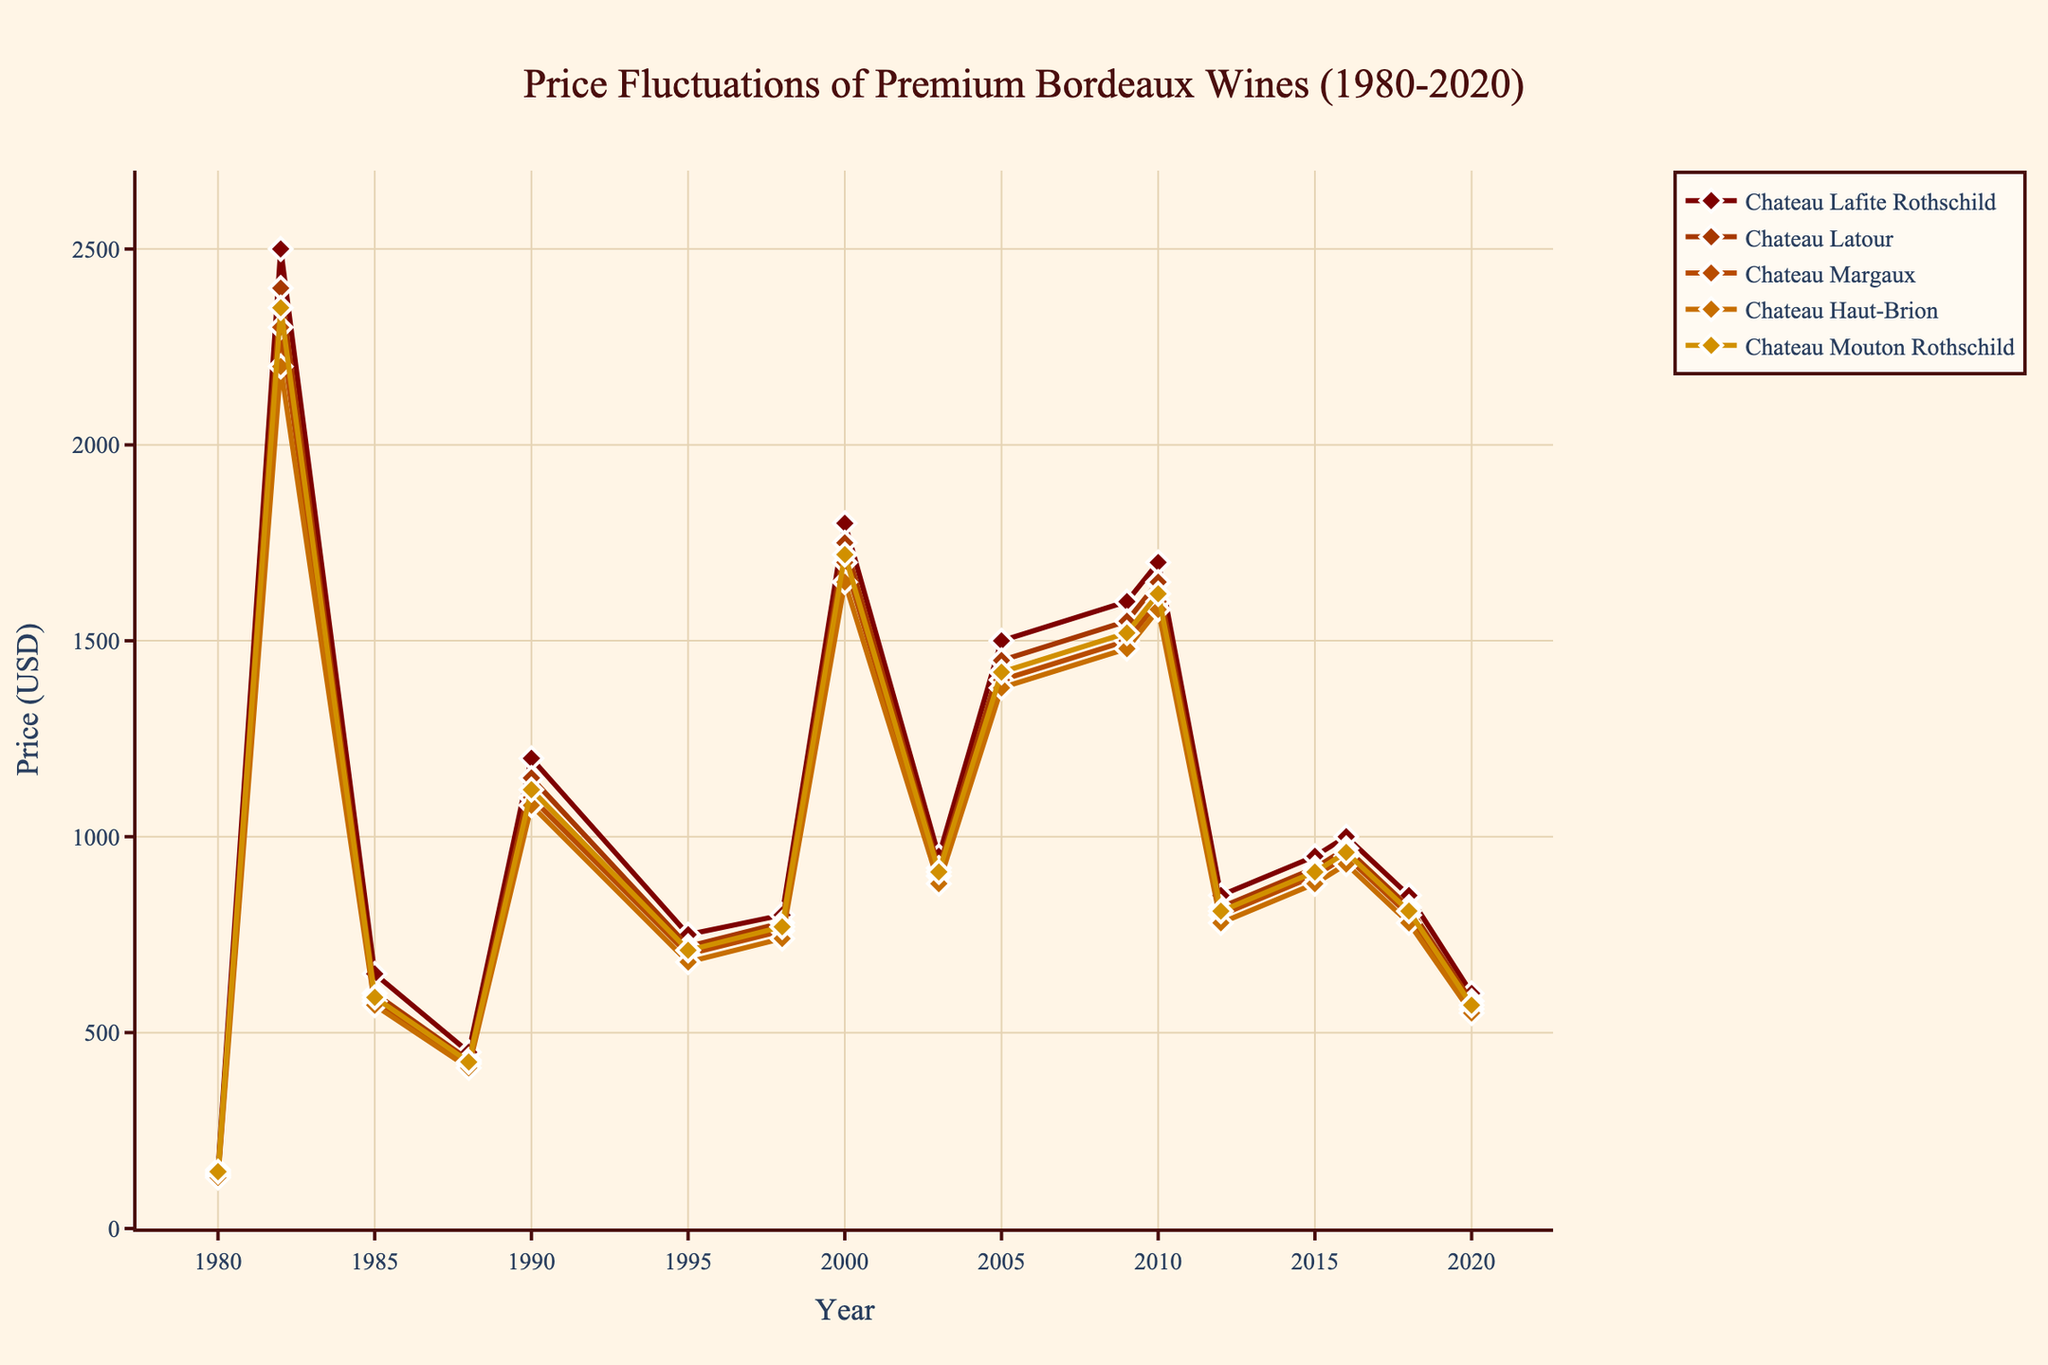Which Chateau had the highest price in 1982? In the figure, the line representing Chateau Lafite Rothschild is the highest among all the Chateaux for the year 1982.
Answer: Chateau Lafite Rothschild How many times did Chateau Latour have the lowest price among the five Chateaux? By examining the figure, Chateau Latour had the lowest price compared to the other four Chateaux in the years: 1985, 1988, 1995, and 2020.
Answer: 4 What is the price difference between Chateau Mouton Rothschild and Chateau Haut-Brion in 2000? From the plot, Chateau Mouton Rothschild was priced at 1720 USD and Chateau Haut-Brion at 1650 USD in the year 2000. The difference is 1720 - 1650 = 70.
Answer: 70 USD Which Chateau's price showed the most significant increase from 1982 to 1985? Comparing the slopes of the lines from 1982 to 1985, Chateau Lafite Rothschild dropped from 2500 to 650, Chateau Latour dropped from 2400 to 600, Chateau Margaux dropped from 2300 to 580, Chateau Haut-Brion dropped from 2200 to 570, and Chateau Mouton Rothschild dropped from 2350 to 590. The largest decrease occurred with Chateau Lafite Rothschild.
Answer: Chateau Lafite Rothschild In which year did all five Chateaux see a simultaneous price increase and what was the price increase for Chateau Haut-Brion from the previous year? All five Chateaux saw a simultaneous price increase between 2009 and 2010. Chateau Haut-Brion's price in 2009 was 1480 USD, and in 2010 it was 1580 USD, so the increase was 100 USD.
Answer: 2010 and 100 USD What was the average price of Chateau Margaux across all recorded years between 1980 and 2020? Total prices for Chateau Margaux for the years listed sum up to 16,445 (135+2300+580+420+1100+700+760+1700+900+1400+1500+1600+800+900+950+800+560). There are 17 years of data points. So, the average price is 16445 / 17 = 967.94 USD.
Answer: 967.94 USD During which period did Chateau Latour see the most prolonged price decrease, and what was the price change? The most prolonged price decrease for Chateau Latour occurred between 2010 and 2020. The price decreased from 1650 USD in 2010 to 580 USD in 2020, equating to a change of 1070 USD.
Answer: 2010-2020 and 1070 USD How many peak points (local maxima) does Chateau Lafite Rothschild have, and what were the years? The plot shows three peaks for Chateau Lafite Rothschild: at 1982, 2000, and 2010.
Answer: 3 and 1982, 2000, 2010 Which Chateau had the most minor price fluctuation (smallest difference between its maximum and minimum prices) from 1980 to 2020? By examining the chart lines, Chateau Haut-Brion appears to have the smallest price range, fluctuating between 550 USD (2020) and 2200 USD (1982). The range is (2200 - 550) = 1650 USD.
Answer: Chateau Haut-Brion 